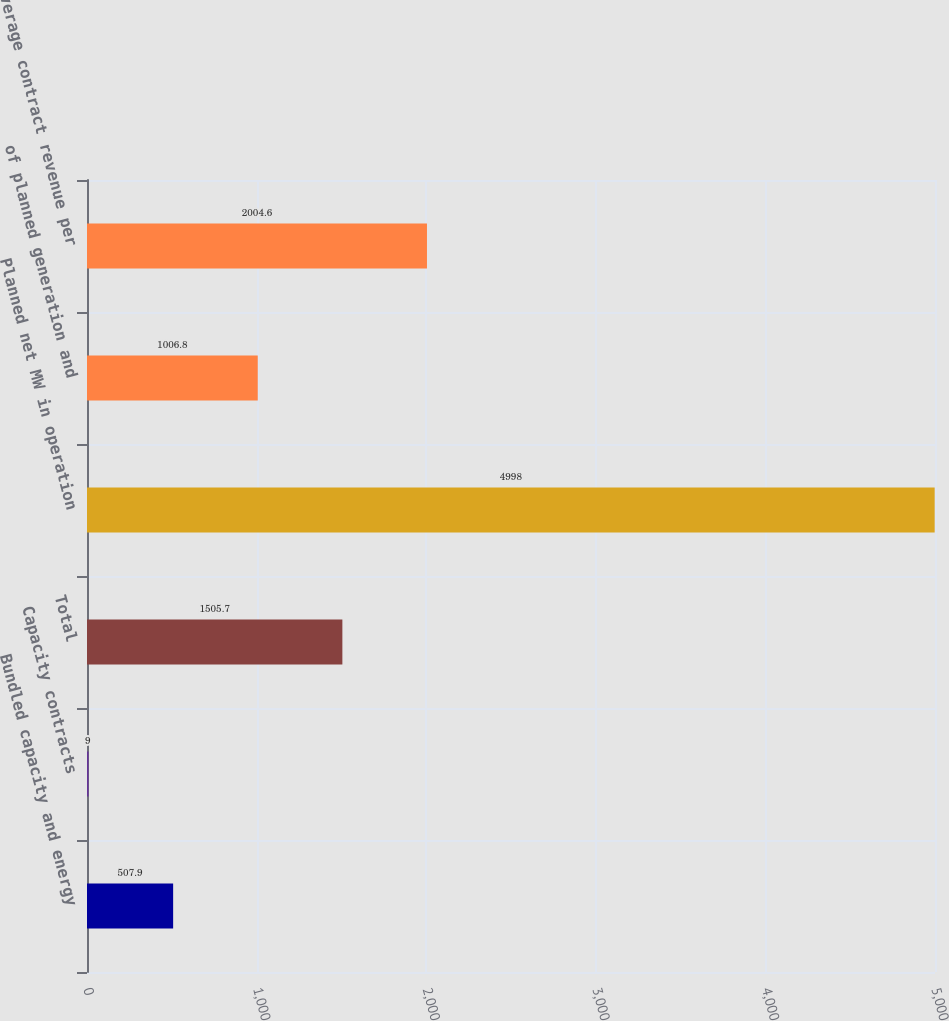Convert chart. <chart><loc_0><loc_0><loc_500><loc_500><bar_chart><fcel>Bundled capacity and energy<fcel>Capacity contracts<fcel>Total<fcel>Planned net MW in operation<fcel>of planned generation and<fcel>Average contract revenue per<nl><fcel>507.9<fcel>9<fcel>1505.7<fcel>4998<fcel>1006.8<fcel>2004.6<nl></chart> 